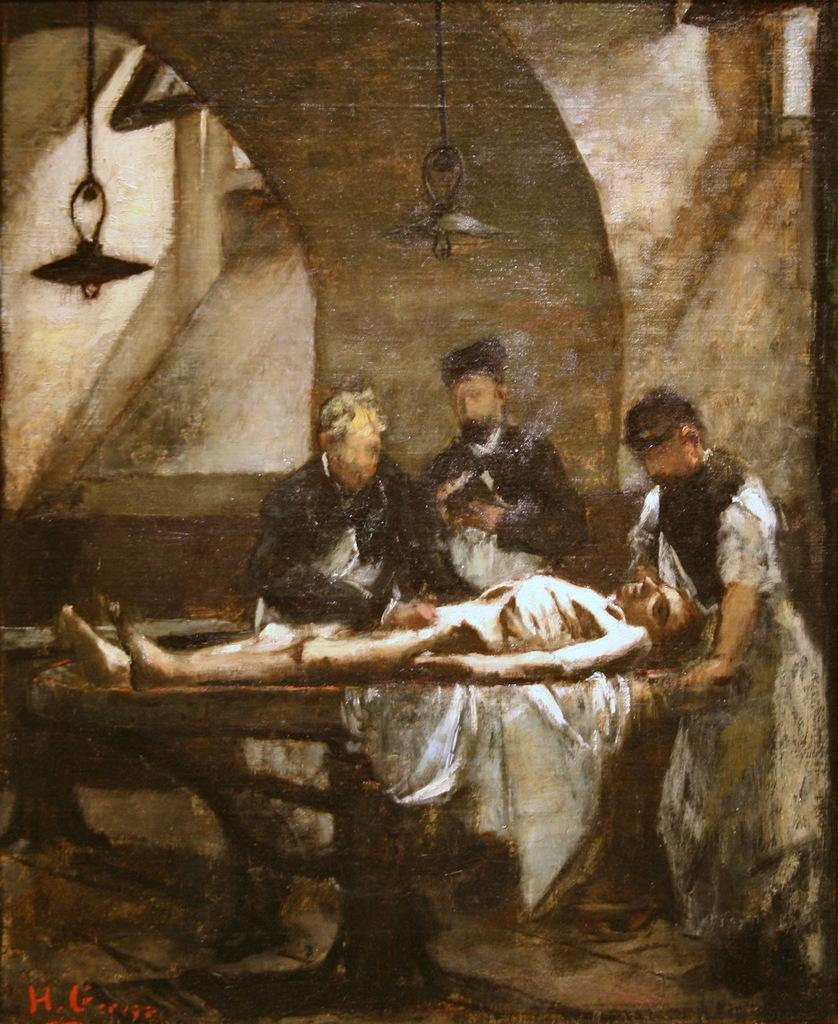How many people are in the image? There are persons in the image. What is one person doing in the image? One person is lying on a table. What type of lighting is present in the image? There are electric lights hanging in the image. What can be seen in the background of the image? There are walls visible in the background of the image. What type of business is being conducted in the image? There is no indication of a business being conducted in the image. Is there a flame visible in the image? There is no flame present in the image. 